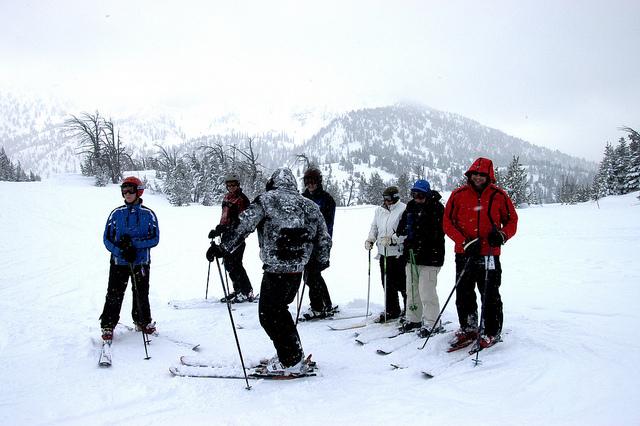How many people are there?
Be succinct. 7. What are they doing?
Give a very brief answer. Skiing. How did the people get here?
Short answer required. Ski lift. 